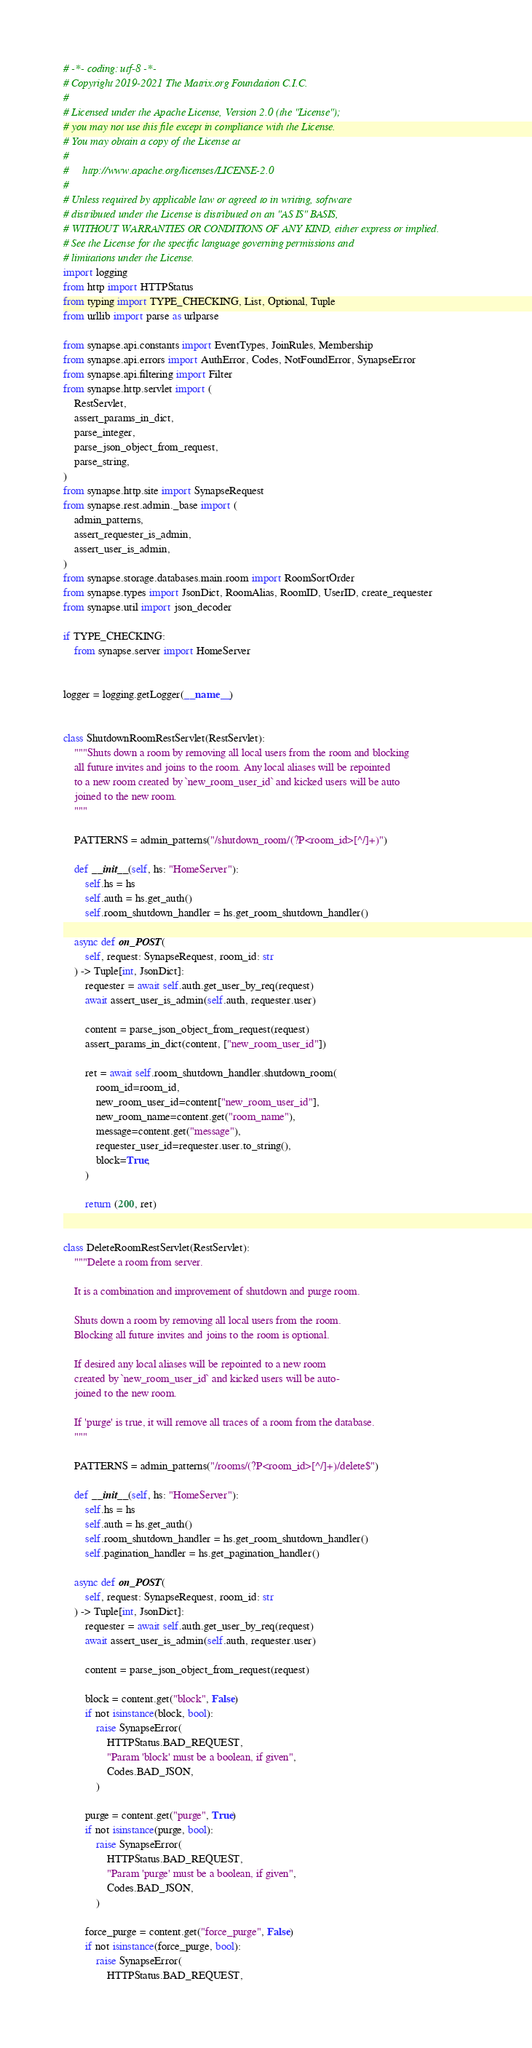Convert code to text. <code><loc_0><loc_0><loc_500><loc_500><_Python_># -*- coding: utf-8 -*-
# Copyright 2019-2021 The Matrix.org Foundation C.I.C.
#
# Licensed under the Apache License, Version 2.0 (the "License");
# you may not use this file except in compliance with the License.
# You may obtain a copy of the License at
#
#     http://www.apache.org/licenses/LICENSE-2.0
#
# Unless required by applicable law or agreed to in writing, software
# distributed under the License is distributed on an "AS IS" BASIS,
# WITHOUT WARRANTIES OR CONDITIONS OF ANY KIND, either express or implied.
# See the License for the specific language governing permissions and
# limitations under the License.
import logging
from http import HTTPStatus
from typing import TYPE_CHECKING, List, Optional, Tuple
from urllib import parse as urlparse

from synapse.api.constants import EventTypes, JoinRules, Membership
from synapse.api.errors import AuthError, Codes, NotFoundError, SynapseError
from synapse.api.filtering import Filter
from synapse.http.servlet import (
    RestServlet,
    assert_params_in_dict,
    parse_integer,
    parse_json_object_from_request,
    parse_string,
)
from synapse.http.site import SynapseRequest
from synapse.rest.admin._base import (
    admin_patterns,
    assert_requester_is_admin,
    assert_user_is_admin,
)
from synapse.storage.databases.main.room import RoomSortOrder
from synapse.types import JsonDict, RoomAlias, RoomID, UserID, create_requester
from synapse.util import json_decoder

if TYPE_CHECKING:
    from synapse.server import HomeServer


logger = logging.getLogger(__name__)


class ShutdownRoomRestServlet(RestServlet):
    """Shuts down a room by removing all local users from the room and blocking
    all future invites and joins to the room. Any local aliases will be repointed
    to a new room created by `new_room_user_id` and kicked users will be auto
    joined to the new room.
    """

    PATTERNS = admin_patterns("/shutdown_room/(?P<room_id>[^/]+)")

    def __init__(self, hs: "HomeServer"):
        self.hs = hs
        self.auth = hs.get_auth()
        self.room_shutdown_handler = hs.get_room_shutdown_handler()

    async def on_POST(
        self, request: SynapseRequest, room_id: str
    ) -> Tuple[int, JsonDict]:
        requester = await self.auth.get_user_by_req(request)
        await assert_user_is_admin(self.auth, requester.user)

        content = parse_json_object_from_request(request)
        assert_params_in_dict(content, ["new_room_user_id"])

        ret = await self.room_shutdown_handler.shutdown_room(
            room_id=room_id,
            new_room_user_id=content["new_room_user_id"],
            new_room_name=content.get("room_name"),
            message=content.get("message"),
            requester_user_id=requester.user.to_string(),
            block=True,
        )

        return (200, ret)


class DeleteRoomRestServlet(RestServlet):
    """Delete a room from server.

    It is a combination and improvement of shutdown and purge room.

    Shuts down a room by removing all local users from the room.
    Blocking all future invites and joins to the room is optional.

    If desired any local aliases will be repointed to a new room
    created by `new_room_user_id` and kicked users will be auto-
    joined to the new room.

    If 'purge' is true, it will remove all traces of a room from the database.
    """

    PATTERNS = admin_patterns("/rooms/(?P<room_id>[^/]+)/delete$")

    def __init__(self, hs: "HomeServer"):
        self.hs = hs
        self.auth = hs.get_auth()
        self.room_shutdown_handler = hs.get_room_shutdown_handler()
        self.pagination_handler = hs.get_pagination_handler()

    async def on_POST(
        self, request: SynapseRequest, room_id: str
    ) -> Tuple[int, JsonDict]:
        requester = await self.auth.get_user_by_req(request)
        await assert_user_is_admin(self.auth, requester.user)

        content = parse_json_object_from_request(request)

        block = content.get("block", False)
        if not isinstance(block, bool):
            raise SynapseError(
                HTTPStatus.BAD_REQUEST,
                "Param 'block' must be a boolean, if given",
                Codes.BAD_JSON,
            )

        purge = content.get("purge", True)
        if not isinstance(purge, bool):
            raise SynapseError(
                HTTPStatus.BAD_REQUEST,
                "Param 'purge' must be a boolean, if given",
                Codes.BAD_JSON,
            )

        force_purge = content.get("force_purge", False)
        if not isinstance(force_purge, bool):
            raise SynapseError(
                HTTPStatus.BAD_REQUEST,</code> 